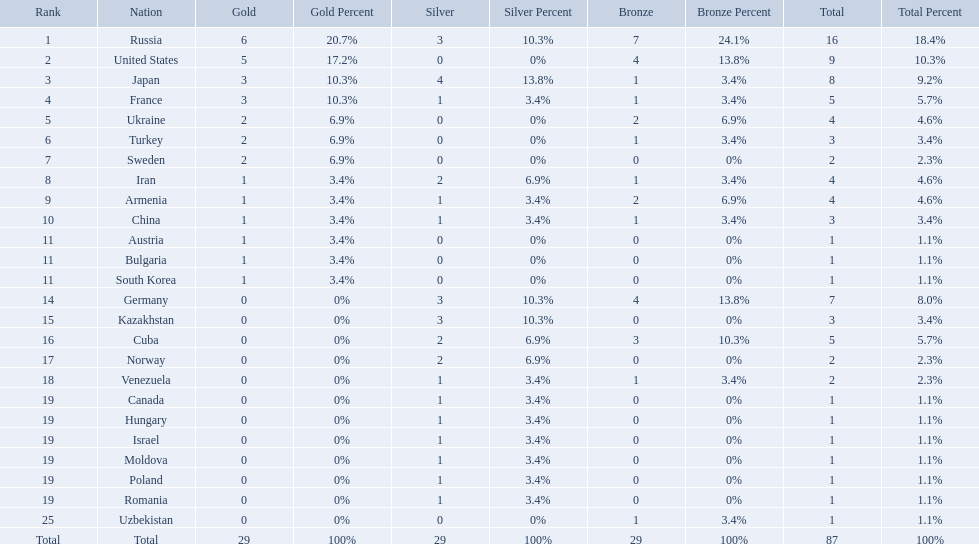Which nations participated in the 1995 world wrestling championships? Russia, United States, Japan, France, Ukraine, Turkey, Sweden, Iran, Armenia, China, Austria, Bulgaria, South Korea, Germany, Kazakhstan, Cuba, Norway, Venezuela, Canada, Hungary, Israel, Moldova, Poland, Romania, Uzbekistan. And between iran and germany, which one placed in the top 10? Germany. Which nations are there? Russia, 6, United States, 5, Japan, 3, France, 3, Ukraine, 2, Turkey, 2, Sweden, 2, Iran, 1, Armenia, 1, China, 1, Austria, 1, Bulgaria, 1, South Korea, 1, Germany, 0, Kazakhstan, 0, Cuba, 0, Norway, 0, Venezuela, 0, Canada, 0, Hungary, 0, Israel, 0, Moldova, 0, Poland, 0, Romania, 0, Uzbekistan, 0. Which nations won gold? Russia, 6, United States, 5, Japan, 3, France, 3, Ukraine, 2, Turkey, 2, Sweden, 2, Iran, 1, Armenia, 1, China, 1, Austria, 1, Bulgaria, 1, South Korea, 1. How many golds did united states win? United States, 5. Which country has more than 5 gold medals? Russia, 6. What country is it? Russia. Which nations participated in the championships? Russia, United States, Japan, France, Ukraine, Turkey, Sweden, Iran, Armenia, China, Austria, Bulgaria, South Korea, Germany, Kazakhstan, Cuba, Norway, Venezuela, Canada, Hungary, Israel, Moldova, Poland, Romania, Uzbekistan. How many bronze medals did they receive? 7, 4, 1, 1, 2, 1, 0, 1, 2, 1, 0, 0, 0, 4, 0, 3, 0, 1, 0, 0, 0, 0, 0, 0, 1, 29. How many in total? 16, 9, 8, 5, 4, 3, 2, 4, 4, 3, 1, 1, 1, 7, 3, 5, 2, 2, 1, 1, 1, 1, 1, 1, 1. And which team won only one medal -- the bronze? Uzbekistan. How many countries competed? Israel. How many total medals did russia win? 16. What country won only 1 medal? Uzbekistan. 